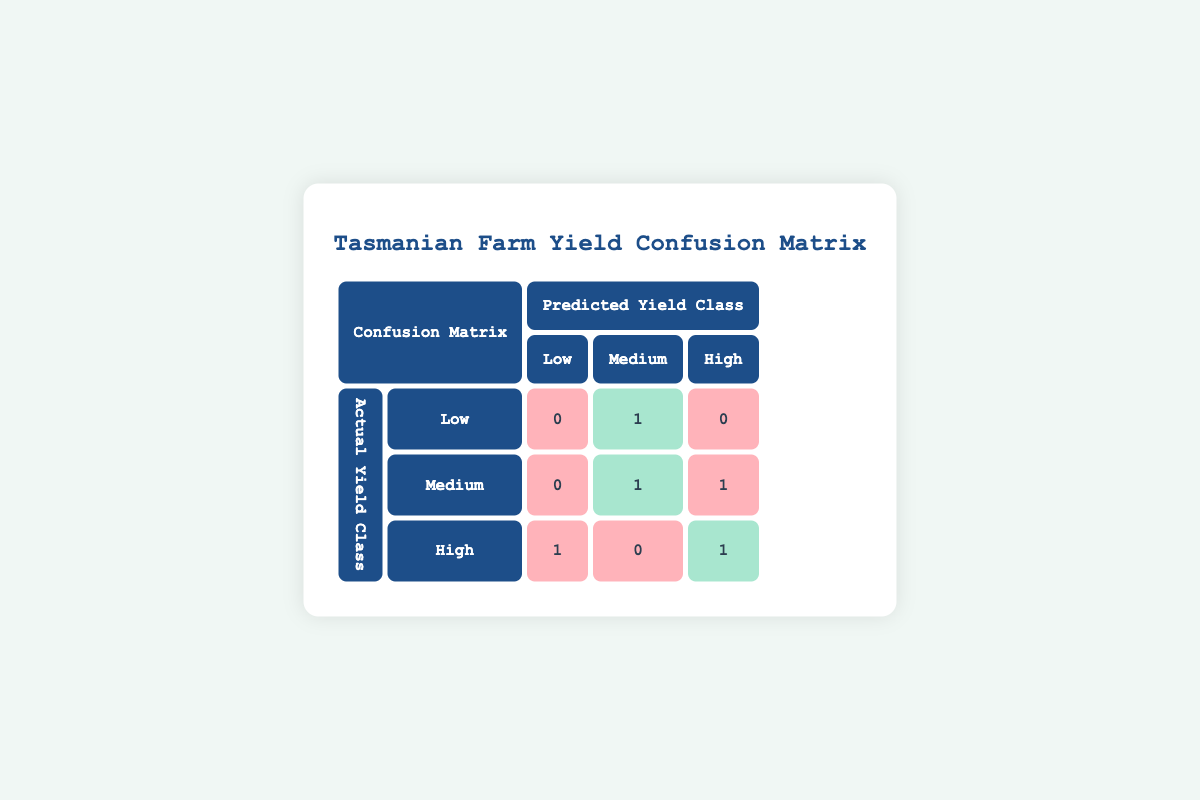What is the number of crops that were predicted to have a low yield? The confusion matrix shows under the "Predicted Yield Class" the "Low" column, which has 0 under "Low," 0 under "Medium," and 1 under "High." Adding these values together gives the total predicted low yield crops as 0.
Answer: 0 How many crops were actually classified as having a medium yield? Looking at the "Actual Yield Class" row for "Medium," the "Medium" column shows the value "1," indicating there was one crop actually classified as medium yield.
Answer: 1 What is the total number of predictions made for high yield crops? The total predictions for high yield crops can be calculated by adding the values in the "High" column: 0 (low) + 1 (medium) + 1 (high) = 2. Thus, the total number of predictions for high yield crops is 2.
Answer: 2 Did any crops that were expected to have a high yield get predicted as having a low yield? Under the "High" actual yield category in the confusion matrix, the cell for the "Low" predicted yield shows "1," meaning that one crop expected to have a high yield was incorrectly predicted as low.
Answer: Yes What is the ratio of correct predictions to total predictions made for all crops? The correct predictions are found by summing the correct counts: 1 correct for Low, 1 for Medium, and 1 for High, giving a total of 3 correct predictions. The total predictions are 5 (one for each crop). Therefore, the ratio of correct predictions to total predictions is 3 correct out of 5, which simplifies to 3:5 or 60%.
Answer: 3:5 How many crops were incorrectly predicted as having a medium yield when they were actually low? From the confusion matrix, under "Low" actual yield, the predicted "Medium" yield has "1," which indicates that one crop was incorrectly classified.
Answer: 1 What is the percentage of crops classified correctly for high yields? The count of correctly classified high yield crops is 1, and the total number of crops expected to have high yields is also 1 (since one crop was classified as high yield). Therefore, the percentage of correct classifications for high yields is (1/1) * 100%, which equals 100%.
Answer: 100% How many crops were incorrectly predicted as high yield when they were actually medium yield? The confusion matrix indicates that for "Medium" yield class, the predicted "High" yield shows "1," indicating one crop was mistakenly predicted as high yield instead of medium.
Answer: 1 